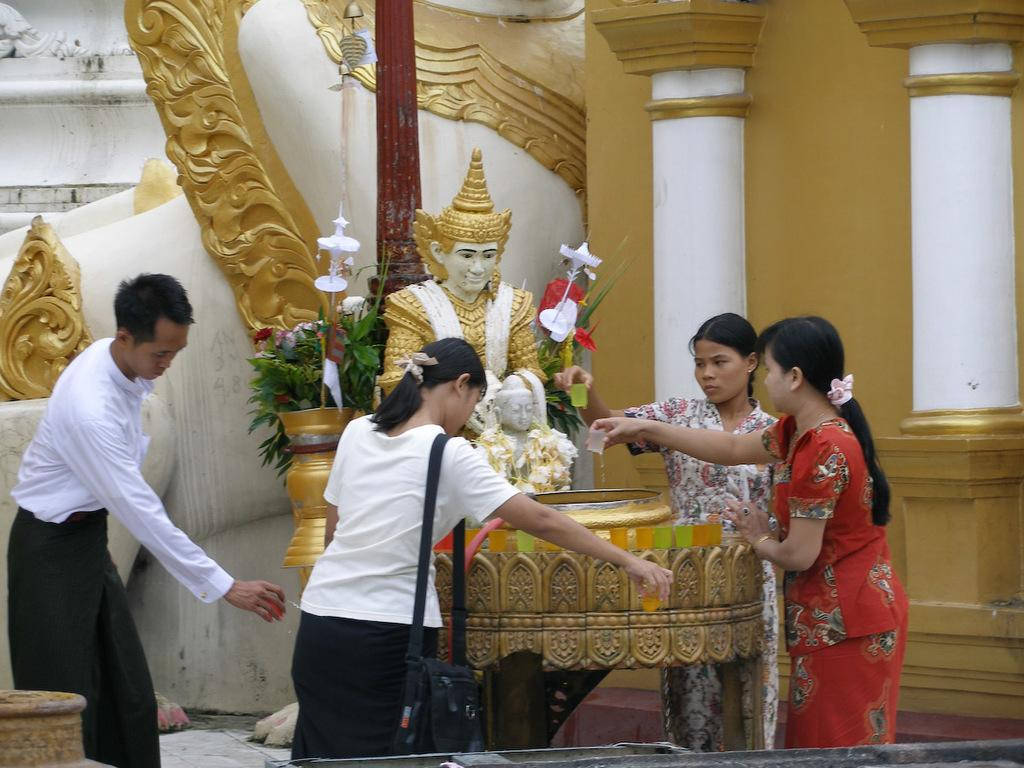How many people are in the image? There are four persons standing in the image. What are the persons holding in the image? The persons are holding objects. What type of structures can be seen in the image? There are statues, pillars, and a wall visible in the image. What type of lace can be seen on the writer's desk in the image? There is no writer or desk present in the image, so there is no lace to be seen. 